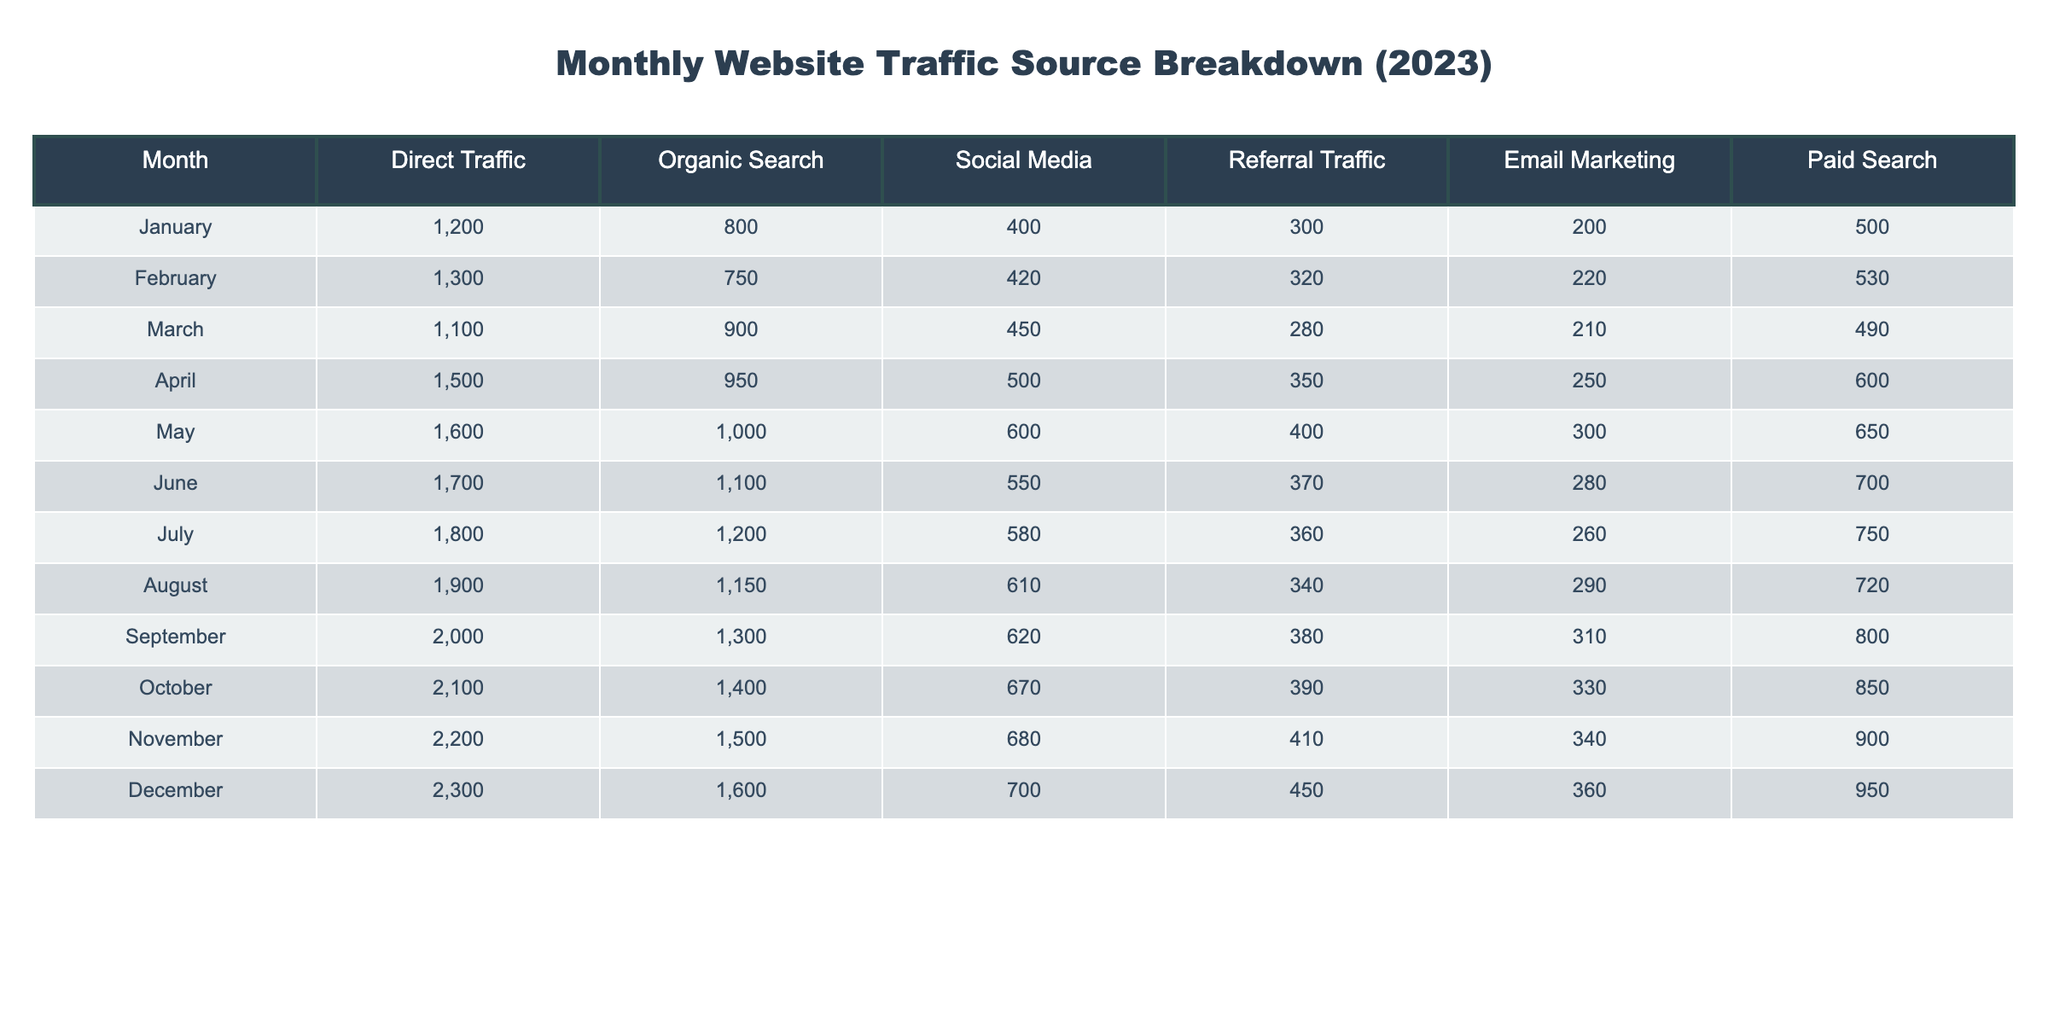What was the total Direct Traffic in December? In the table, under the month of December, the value for Direct Traffic is listed as 2300.
Answer: 2300 What is the maximum value for Paid Search in any month? The table shows that the highest value for Paid Search occurs in December, where it is 950.
Answer: 950 What was the average Organic Search traffic across all months? The Organic Search values across the months are: 800, 750, 900, 950, 1000, 1100, 1200, 1150, 1300, 1400, 1500, and 1600. To find the average, sum these values (800 + 750 + 900 + 950 + 1000 + 1100 + 1200 + 1150 + 1300 + 1400 + 1500 + 1600 = 13700) and divide by the number of months (12): 13700 / 12 = 1141.67.
Answer: 1141.67 Which month had the highest traffic from Social Media? By examining the Social Media column, the value peaks in August at 610, which is higher than all other months.
Answer: August Was there a month where Organic Search traffic decreased compared to the previous month? Looking at the values for Organic Search, it can be observed that there is a decrease from February (750) to March (900), and then again from June (1100) to July (1200). Hence, there were no months where Organic Search traffic decreased month-over-month.
Answer: No Which traffic source had the overall highest increase from January to December? To find the highest increase, we compare the starting values in January and the values for December for each traffic source. For Direct Traffic, it increased from 1200 to 2300 (an increase of 1100), for Organic Search it went from 800 to 1600 (an increase of 800), for Social Media from 400 to 700 (an increase of 300), for Referral Traffic from 300 to 450 (an increase of 150), for Email Marketing from 200 to 360 (an increase of 160), and for Paid Search from 500 to 950 (an increase of 450). The highest overall increase is for Direct Traffic, which increased by 1100.
Answer: Direct Traffic During which month did Social Media traffic exceed 600? According to the Social Media values, only in August does the traffic exceed 600 with a value of 610; all preceding months have numbers below this level.
Answer: August What is the combined traffic from Email Marketing and Paid Search in October? The values for Email Marketing and Paid Search in October are 330 and 850, respectively. Adding these two values together gives us 330 + 850 = 1180.
Answer: 1180 In which month was Referral Traffic at its lowest? By checking the Referral Traffic values, the lowest point occurs in March, where it is listed as 280, which is lower than all other months.
Answer: March What was the total traffic across all sources in September? To find the total traffic for September, we sum all traffic sources: Direct Traffic (2000) + Organic Search (1300) + Social Media (620) + Referral Traffic (380) + Email Marketing (310) + Paid Search (800) = 2000 + 1300 + 620 + 380 + 310 + 800 = 4910.
Answer: 4910 